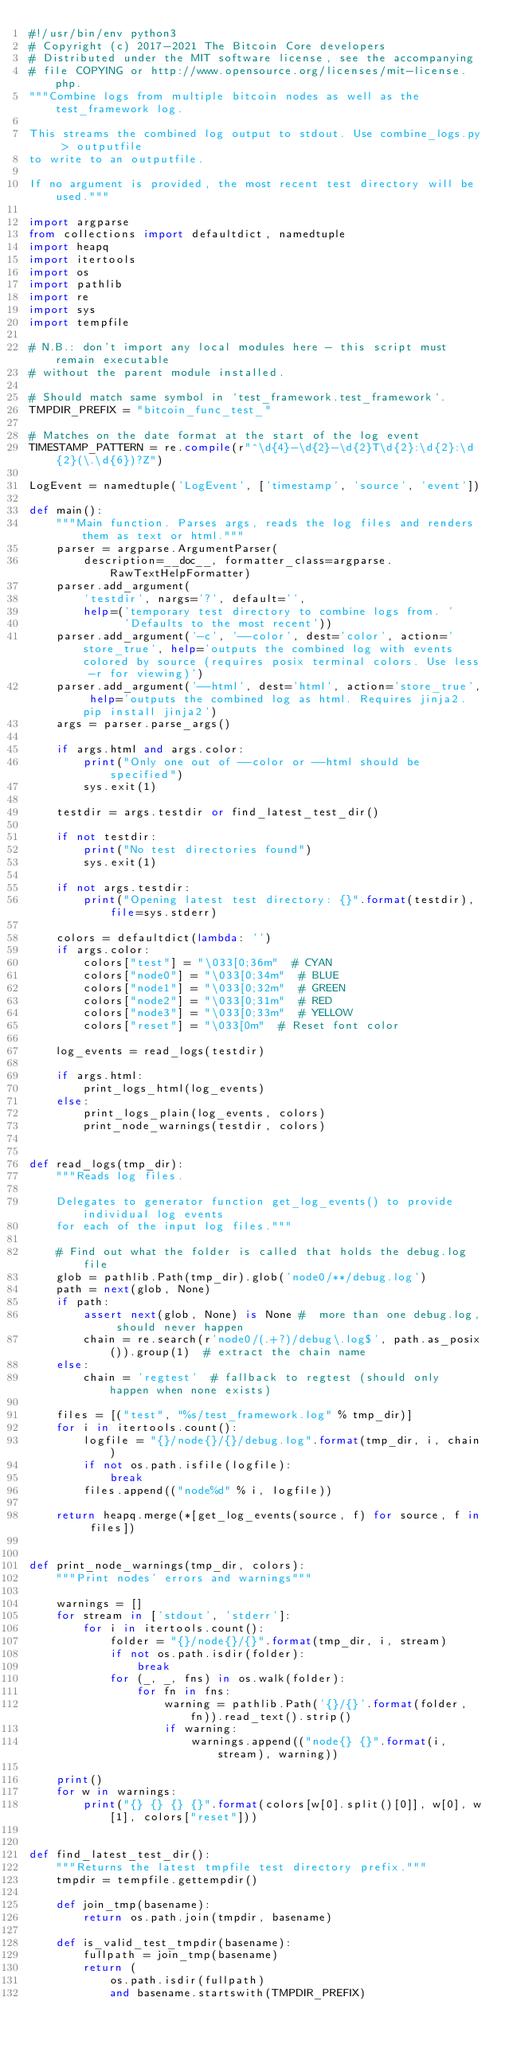<code> <loc_0><loc_0><loc_500><loc_500><_Python_>#!/usr/bin/env python3
# Copyright (c) 2017-2021 The Bitcoin Core developers
# Distributed under the MIT software license, see the accompanying
# file COPYING or http://www.opensource.org/licenses/mit-license.php.
"""Combine logs from multiple bitcoin nodes as well as the test_framework log.

This streams the combined log output to stdout. Use combine_logs.py > outputfile
to write to an outputfile.

If no argument is provided, the most recent test directory will be used."""

import argparse
from collections import defaultdict, namedtuple
import heapq
import itertools
import os
import pathlib
import re
import sys
import tempfile

# N.B.: don't import any local modules here - this script must remain executable
# without the parent module installed.

# Should match same symbol in `test_framework.test_framework`.
TMPDIR_PREFIX = "bitcoin_func_test_"

# Matches on the date format at the start of the log event
TIMESTAMP_PATTERN = re.compile(r"^\d{4}-\d{2}-\d{2}T\d{2}:\d{2}:\d{2}(\.\d{6})?Z")

LogEvent = namedtuple('LogEvent', ['timestamp', 'source', 'event'])

def main():
    """Main function. Parses args, reads the log files and renders them as text or html."""
    parser = argparse.ArgumentParser(
        description=__doc__, formatter_class=argparse.RawTextHelpFormatter)
    parser.add_argument(
        'testdir', nargs='?', default='',
        help=('temporary test directory to combine logs from. '
              'Defaults to the most recent'))
    parser.add_argument('-c', '--color', dest='color', action='store_true', help='outputs the combined log with events colored by source (requires posix terminal colors. Use less -r for viewing)')
    parser.add_argument('--html', dest='html', action='store_true', help='outputs the combined log as html. Requires jinja2. pip install jinja2')
    args = parser.parse_args()

    if args.html and args.color:
        print("Only one out of --color or --html should be specified")
        sys.exit(1)

    testdir = args.testdir or find_latest_test_dir()

    if not testdir:
        print("No test directories found")
        sys.exit(1)

    if not args.testdir:
        print("Opening latest test directory: {}".format(testdir), file=sys.stderr)

    colors = defaultdict(lambda: '')
    if args.color:
        colors["test"] = "\033[0;36m"  # CYAN
        colors["node0"] = "\033[0;34m"  # BLUE
        colors["node1"] = "\033[0;32m"  # GREEN
        colors["node2"] = "\033[0;31m"  # RED
        colors["node3"] = "\033[0;33m"  # YELLOW
        colors["reset"] = "\033[0m"  # Reset font color

    log_events = read_logs(testdir)

    if args.html:
        print_logs_html(log_events)
    else:
        print_logs_plain(log_events, colors)
        print_node_warnings(testdir, colors)


def read_logs(tmp_dir):
    """Reads log files.

    Delegates to generator function get_log_events() to provide individual log events
    for each of the input log files."""

    # Find out what the folder is called that holds the debug.log file
    glob = pathlib.Path(tmp_dir).glob('node0/**/debug.log')
    path = next(glob, None)
    if path:
        assert next(glob, None) is None #  more than one debug.log, should never happen
        chain = re.search(r'node0/(.+?)/debug\.log$', path.as_posix()).group(1)  # extract the chain name
    else:
        chain = 'regtest'  # fallback to regtest (should only happen when none exists)

    files = [("test", "%s/test_framework.log" % tmp_dir)]
    for i in itertools.count():
        logfile = "{}/node{}/{}/debug.log".format(tmp_dir, i, chain)
        if not os.path.isfile(logfile):
            break
        files.append(("node%d" % i, logfile))

    return heapq.merge(*[get_log_events(source, f) for source, f in files])


def print_node_warnings(tmp_dir, colors):
    """Print nodes' errors and warnings"""

    warnings = []
    for stream in ['stdout', 'stderr']:
        for i in itertools.count():
            folder = "{}/node{}/{}".format(tmp_dir, i, stream)
            if not os.path.isdir(folder):
                break
            for (_, _, fns) in os.walk(folder):
                for fn in fns:
                    warning = pathlib.Path('{}/{}'.format(folder, fn)).read_text().strip()
                    if warning:
                        warnings.append(("node{} {}".format(i, stream), warning))

    print()
    for w in warnings:
        print("{} {} {} {}".format(colors[w[0].split()[0]], w[0], w[1], colors["reset"]))


def find_latest_test_dir():
    """Returns the latest tmpfile test directory prefix."""
    tmpdir = tempfile.gettempdir()

    def join_tmp(basename):
        return os.path.join(tmpdir, basename)

    def is_valid_test_tmpdir(basename):
        fullpath = join_tmp(basename)
        return (
            os.path.isdir(fullpath)
            and basename.startswith(TMPDIR_PREFIX)</code> 